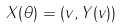<formula> <loc_0><loc_0><loc_500><loc_500>X ( \theta ) = ( v , Y ( v ) )</formula> 